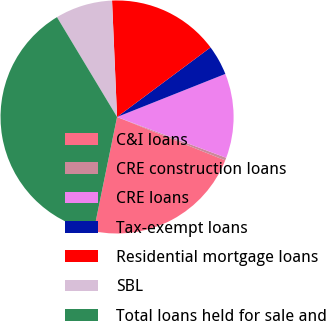<chart> <loc_0><loc_0><loc_500><loc_500><pie_chart><fcel>C&I loans<fcel>CRE construction loans<fcel>CRE loans<fcel>Tax-exempt loans<fcel>Residential mortgage loans<fcel>SBL<fcel>Total loans held for sale and<nl><fcel>22.14%<fcel>0.38%<fcel>11.72%<fcel>4.16%<fcel>15.5%<fcel>7.94%<fcel>38.17%<nl></chart> 